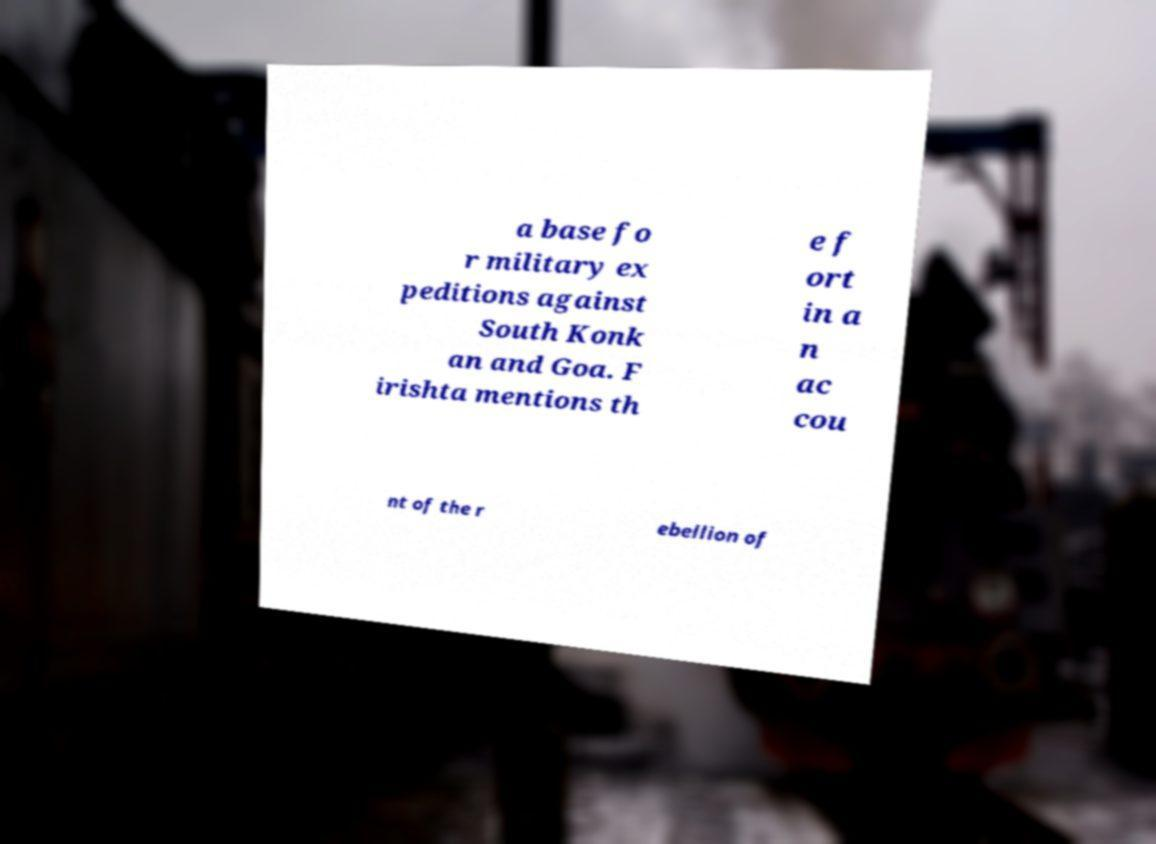There's text embedded in this image that I need extracted. Can you transcribe it verbatim? a base fo r military ex peditions against South Konk an and Goa. F irishta mentions th e f ort in a n ac cou nt of the r ebellion of 